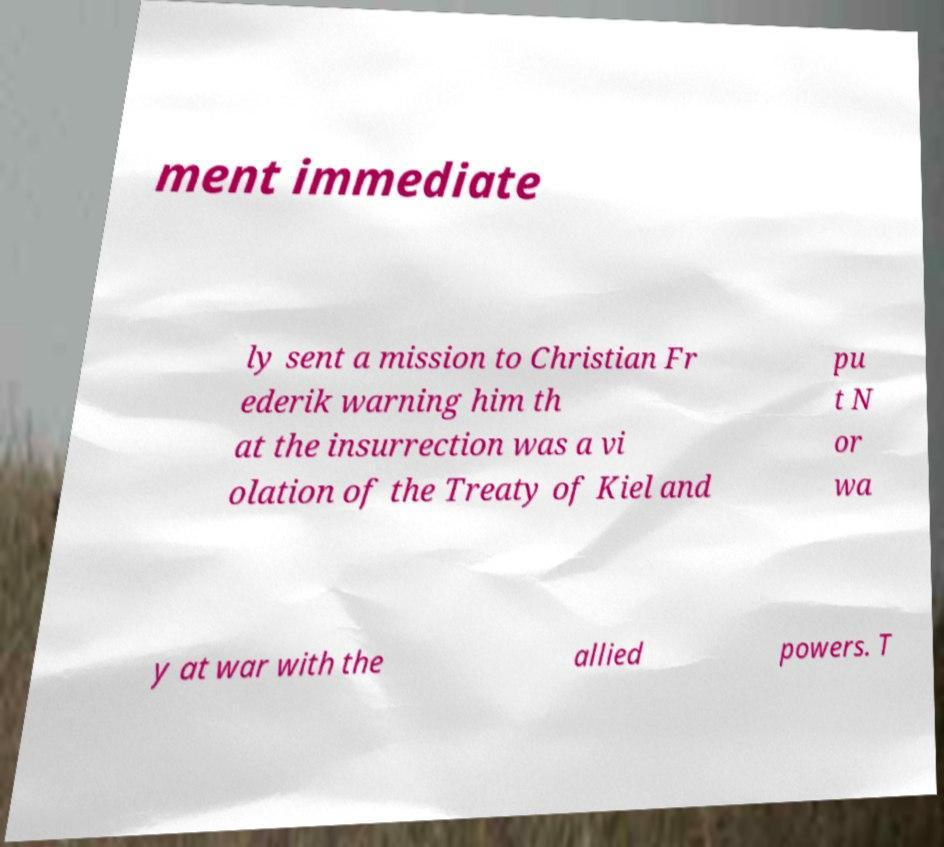Could you assist in decoding the text presented in this image and type it out clearly? ment immediate ly sent a mission to Christian Fr ederik warning him th at the insurrection was a vi olation of the Treaty of Kiel and pu t N or wa y at war with the allied powers. T 